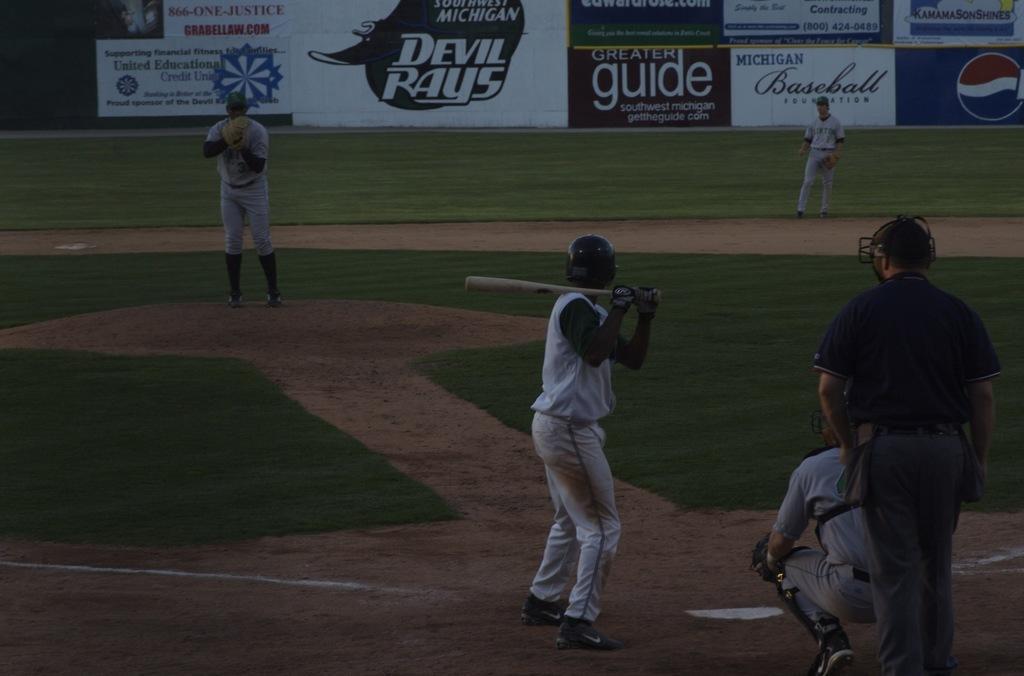Describe this image in one or two sentences. The man in front of the picture wearing white T-shirt is holding a baseball bat in his hand. Behind him, the man in blue T-shirt is standing and the man in grey T-shirt is in squad position. In the background, we see two men standing. At the bottom of the picture, we see grass. In the background, we see a board in white color with some text written on it. 